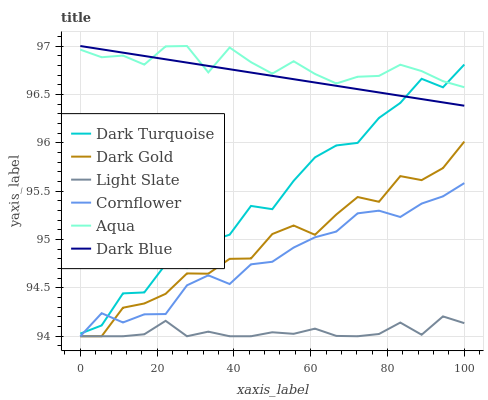Does Light Slate have the minimum area under the curve?
Answer yes or no. Yes. Does Aqua have the maximum area under the curve?
Answer yes or no. Yes. Does Dark Gold have the minimum area under the curve?
Answer yes or no. No. Does Dark Gold have the maximum area under the curve?
Answer yes or no. No. Is Dark Blue the smoothest?
Answer yes or no. Yes. Is Dark Turquoise the roughest?
Answer yes or no. Yes. Is Dark Gold the smoothest?
Answer yes or no. No. Is Dark Gold the roughest?
Answer yes or no. No. Does Cornflower have the lowest value?
Answer yes or no. Yes. Does Dark Turquoise have the lowest value?
Answer yes or no. No. Does Dark Blue have the highest value?
Answer yes or no. Yes. Does Dark Gold have the highest value?
Answer yes or no. No. Is Light Slate less than Aqua?
Answer yes or no. Yes. Is Dark Turquoise greater than Dark Gold?
Answer yes or no. Yes. Does Dark Blue intersect Aqua?
Answer yes or no. Yes. Is Dark Blue less than Aqua?
Answer yes or no. No. Is Dark Blue greater than Aqua?
Answer yes or no. No. Does Light Slate intersect Aqua?
Answer yes or no. No. 